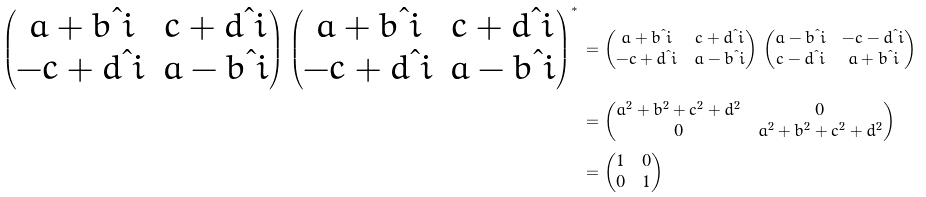Convert formula to latex. <formula><loc_0><loc_0><loc_500><loc_500>\begin{pmatrix} a + b \i i & c + d \i i \\ - c + d \i i & a - b \i i \end{pmatrix} \, \begin{pmatrix} a + b \i i & c + d \i i \\ - c + d \i i & a - b \i i \end{pmatrix} ^ { \ast } \, = \, & \begin{pmatrix} a + b \i i & c + d \i i \\ - c + d \i i & a - b \i i \end{pmatrix} \, \begin{pmatrix} a - b \i i & - c - d \i i \\ c - d \i i & a + b \i i \end{pmatrix} \\ = \, & \begin{pmatrix} a ^ { 2 } + b ^ { 2 } + c ^ { 2 } + d ^ { 2 } & 0 \\ 0 & a ^ { 2 } + b ^ { 2 } + c ^ { 2 } + d ^ { 2 } \end{pmatrix} \\ = \, & \begin{pmatrix} 1 & 0 \\ 0 & 1 \end{pmatrix}</formula> 